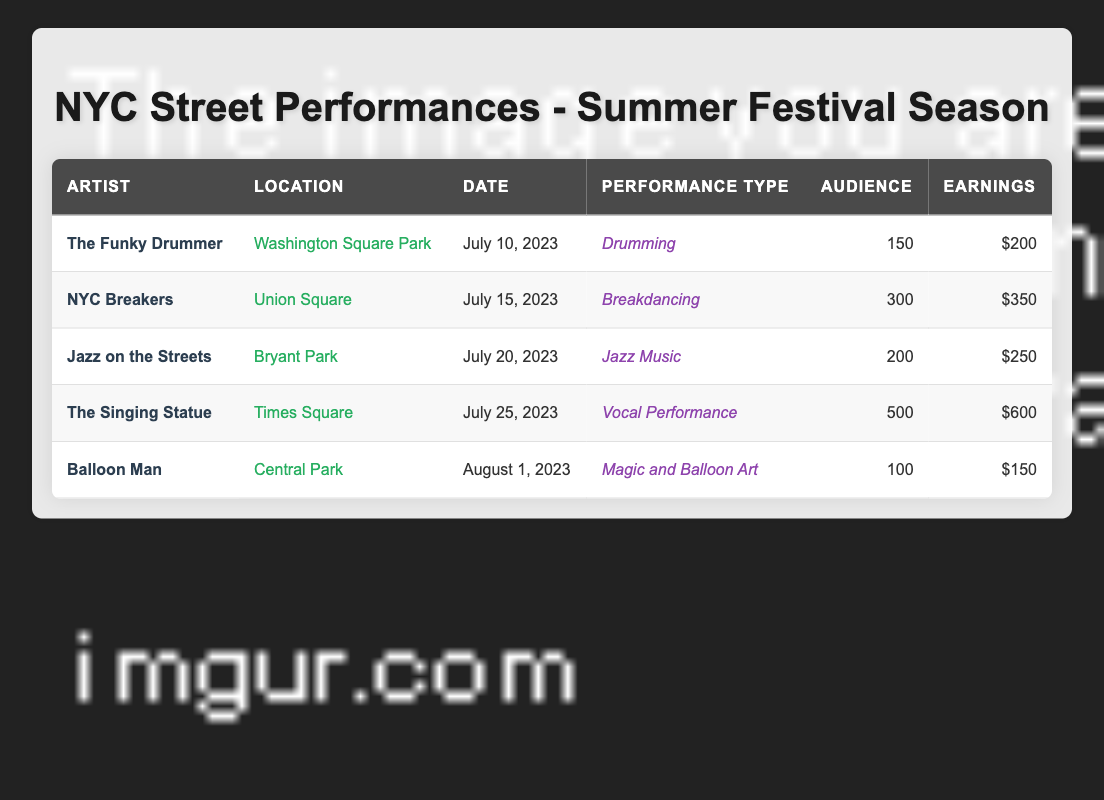What is the performance type of The Singing Statue? The table lists The Singing Statue's performance type in the corresponding row under the "Performance Type" column. It shows "Vocal Performance."
Answer: Vocal Performance Where did NYC Breakers perform? The "Location" column for NYC Breakers indicates that they performed at Union Square.
Answer: Union Square What was the audience size for the performance on July 20, 2023? Referring to the performance date of July 20 in the table, the row lists an audience size of 200 for Jazz on the Streets.
Answer: 200 Which performance had the highest earnings, and what were they? By comparing the "Earnings" column values, it’s clear that The Singing Statue earned the most at 600.
Answer: 600 What is the total earnings of all street performances listed? To find total earnings, we add the values from the "Earnings" column: 200 + 350 + 250 + 600 + 150 = 1600.
Answer: 1600 Did any of the performers earn less than 200? Looking through the "Earnings" column, Balloon Man earned 150, which is less than 200.
Answer: Yes What was the average audience size across all performances? We first find the total audience size: 150 + 300 + 200 + 500 + 100 = 1250. Then, we divide the total by the number of performances (5): 1250 / 5 = 250.
Answer: 250 Which two locations had performances with audience sizes greater than 250? Checking the "Audience" column, only The Singing Statue at Times Square (500) and NYC Breakers at Union Square (300) had more than 250 attendees.
Answer: Times Square, Union Square What percentage of the total audience size was accounted for by The Singing Statue? The total audience size is 1250, while The Singing Statue's audience is 500. To find the percentage: (500 / 1250) * 100 = 40%.
Answer: 40% 